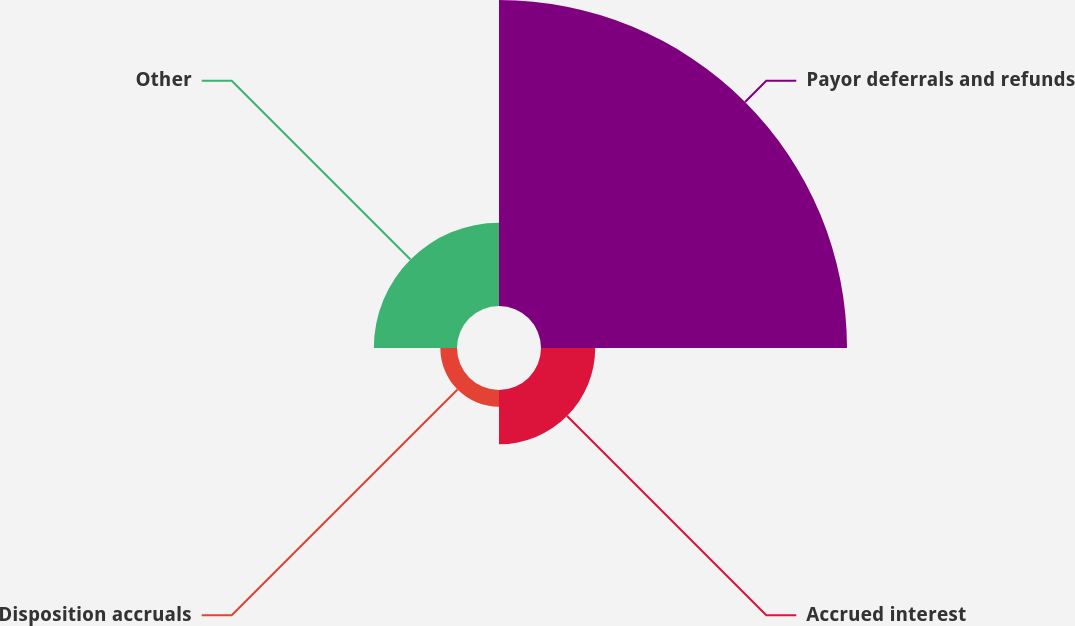Convert chart. <chart><loc_0><loc_0><loc_500><loc_500><pie_chart><fcel>Payor deferrals and refunds<fcel>Accrued interest<fcel>Disposition accruals<fcel>Other<nl><fcel>66.52%<fcel>11.79%<fcel>3.62%<fcel>18.08%<nl></chart> 